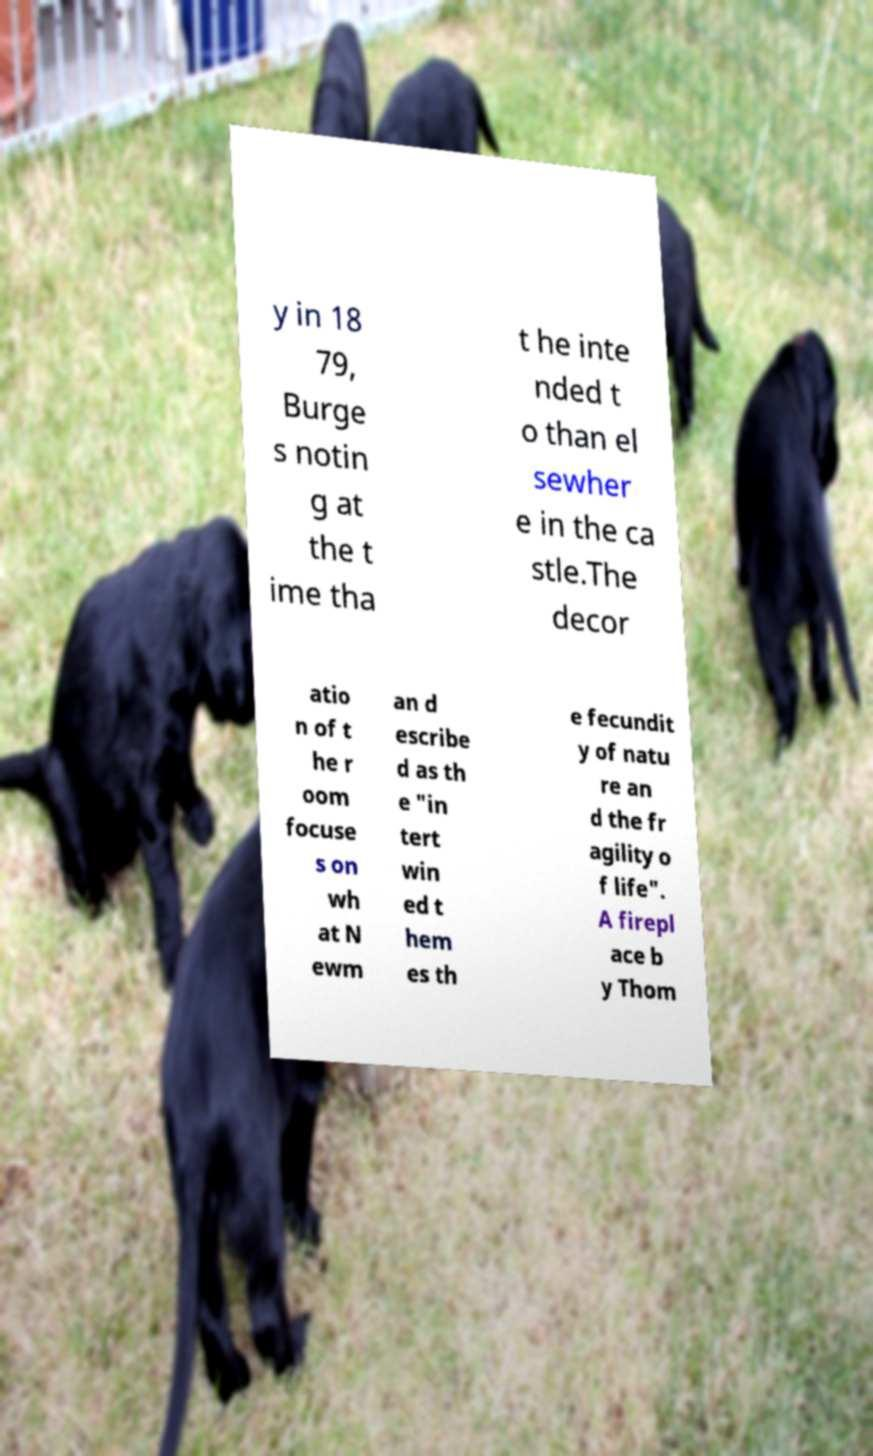I need the written content from this picture converted into text. Can you do that? y in 18 79, Burge s notin g at the t ime tha t he inte nded t o than el sewher e in the ca stle.The decor atio n of t he r oom focuse s on wh at N ewm an d escribe d as th e "in tert win ed t hem es th e fecundit y of natu re an d the fr agility o f life". A firepl ace b y Thom 